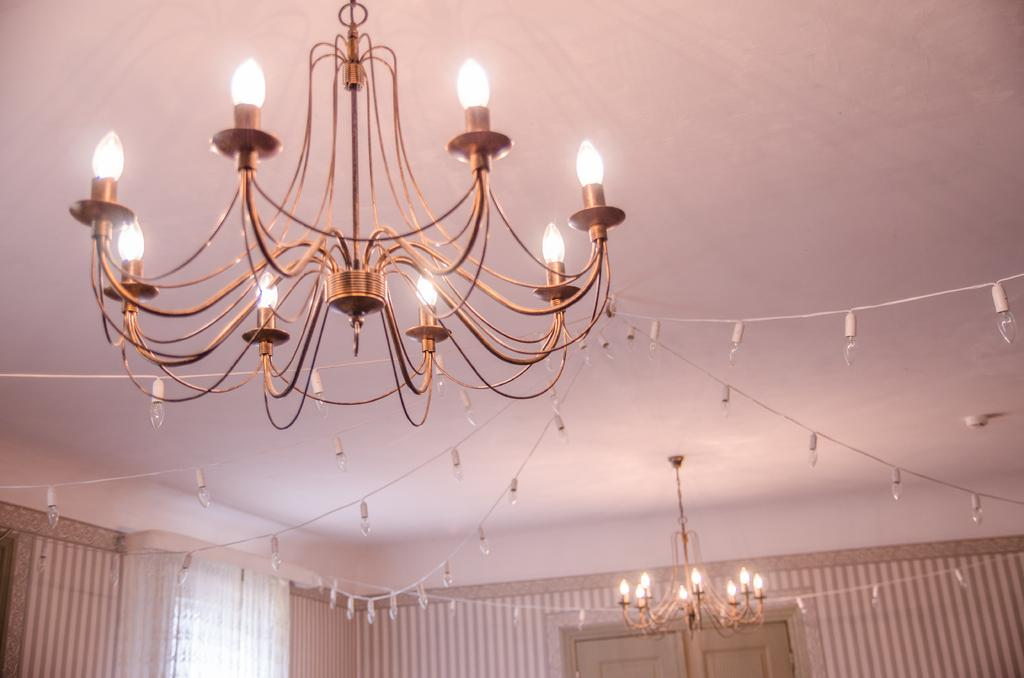How many chandeliers can be seen in the image? There are two chandeliers in the image. What type of lighting is present on the ceiling? String lights are decorated on the ceiling. What can be seen on the wall in the image? There is a wall visible in the image. Can you describe any other objects present in the image? There are other objects present in the image, but their specific details are not mentioned in the provided facts. What type of pizzas are being served in the image? There is no mention of pizzas in the provided facts, so it cannot be determined if they are present in the image. 